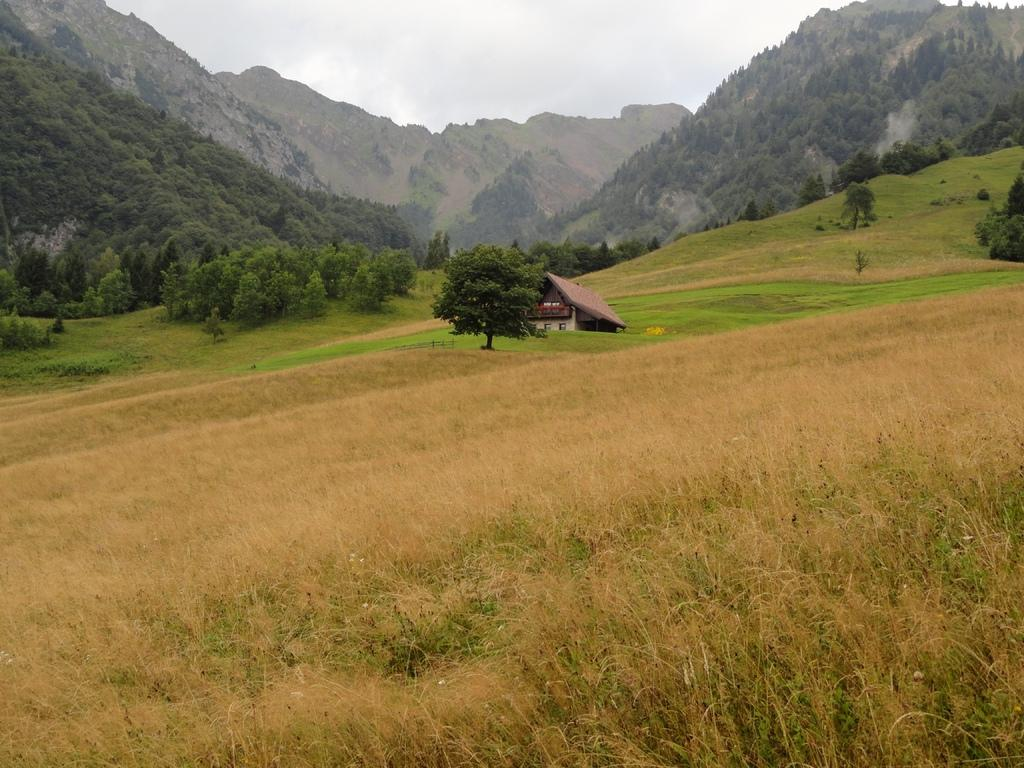What type of structure is visible in the image? There is a house in the image. What natural features can be seen in the image? There are mountains and trees visible in the image. What is visible at the top of the image? The sky is visible at the top of the image, and there are clouds in the sky. What type of vegetation is present at the bottom of the image? Grass is present at the bottom of the image. What type of business is being conducted in the image? There is no indication of a business or any commercial activity in the image. Can you see a flame in the image? There is no flame present in the image. 